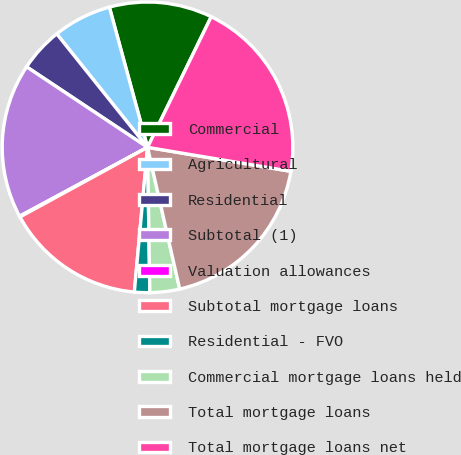Convert chart to OTSL. <chart><loc_0><loc_0><loc_500><loc_500><pie_chart><fcel>Commercial<fcel>Agricultural<fcel>Residential<fcel>Subtotal (1)<fcel>Valuation allowances<fcel>Subtotal mortgage loans<fcel>Residential - FVO<fcel>Commercial mortgage loans held<fcel>Total mortgage loans<fcel>Total mortgage loans net<nl><fcel>11.45%<fcel>6.51%<fcel>4.91%<fcel>17.21%<fcel>0.09%<fcel>15.6%<fcel>1.7%<fcel>3.3%<fcel>18.81%<fcel>20.42%<nl></chart> 